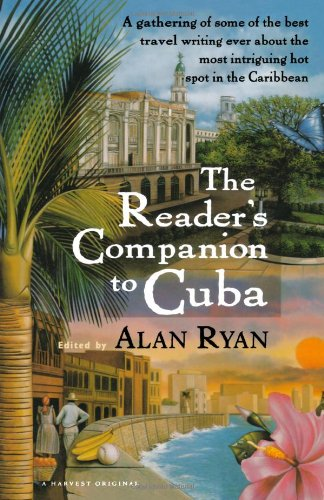Is this book related to Children's Books? No, this book is not related to children's literature; it's targeted towards travelers and those interested in Cuban culture and places. 